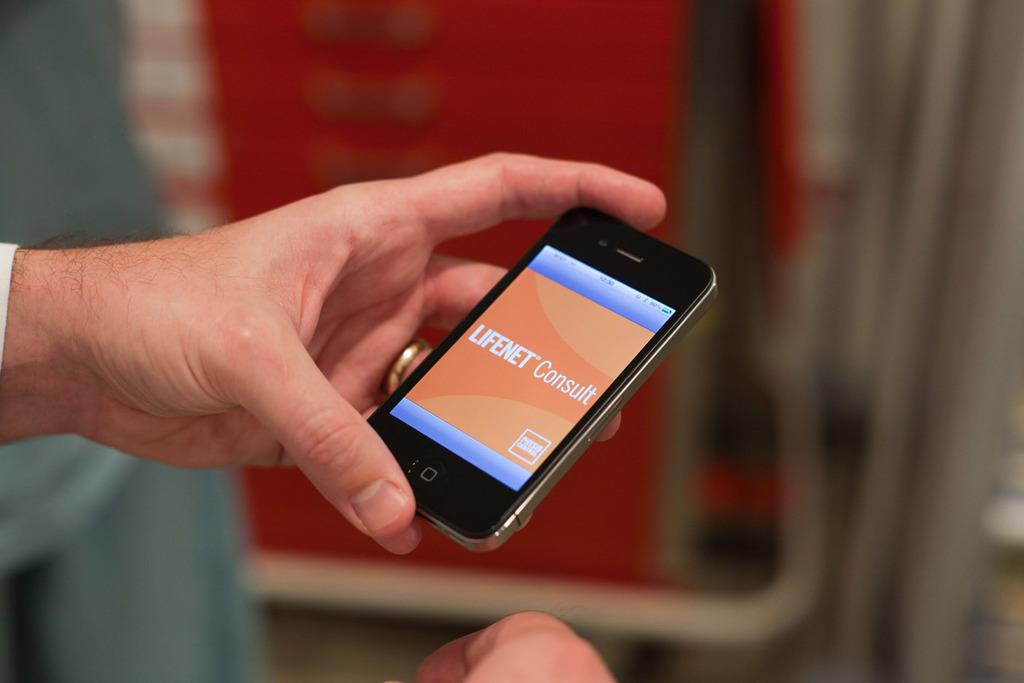<image>
Create a compact narrative representing the image presented. A person hold a cellphone that is showing the app screen of Lifenet Consult. 